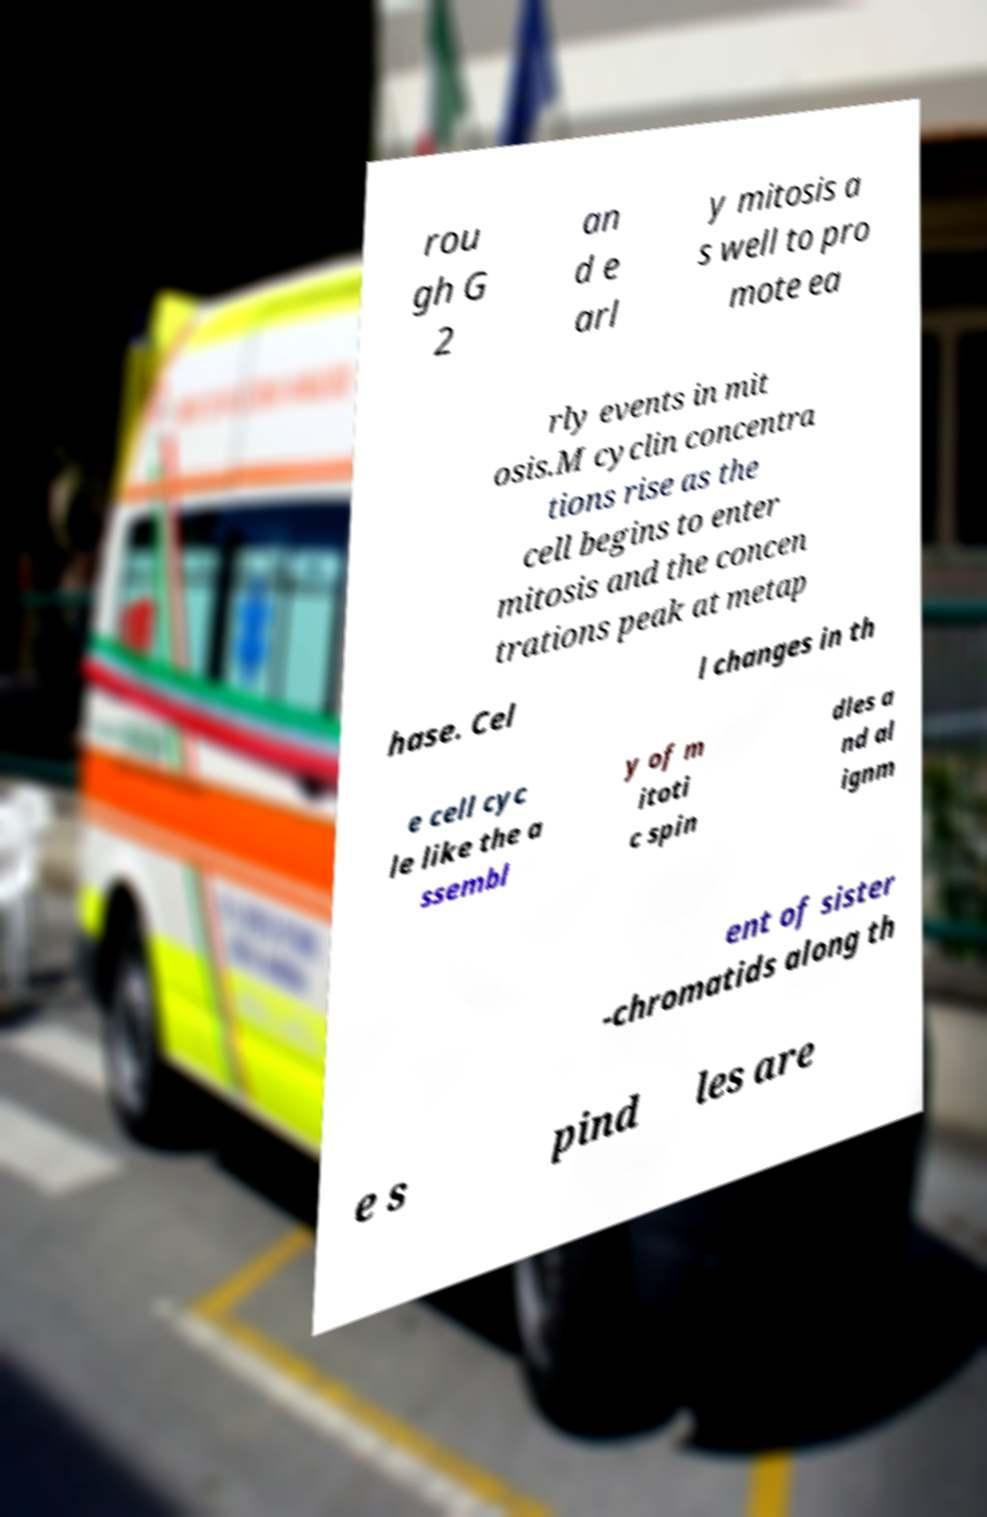Please identify and transcribe the text found in this image. rou gh G 2 an d e arl y mitosis a s well to pro mote ea rly events in mit osis.M cyclin concentra tions rise as the cell begins to enter mitosis and the concen trations peak at metap hase. Cel l changes in th e cell cyc le like the a ssembl y of m itoti c spin dles a nd al ignm ent of sister -chromatids along th e s pind les are 